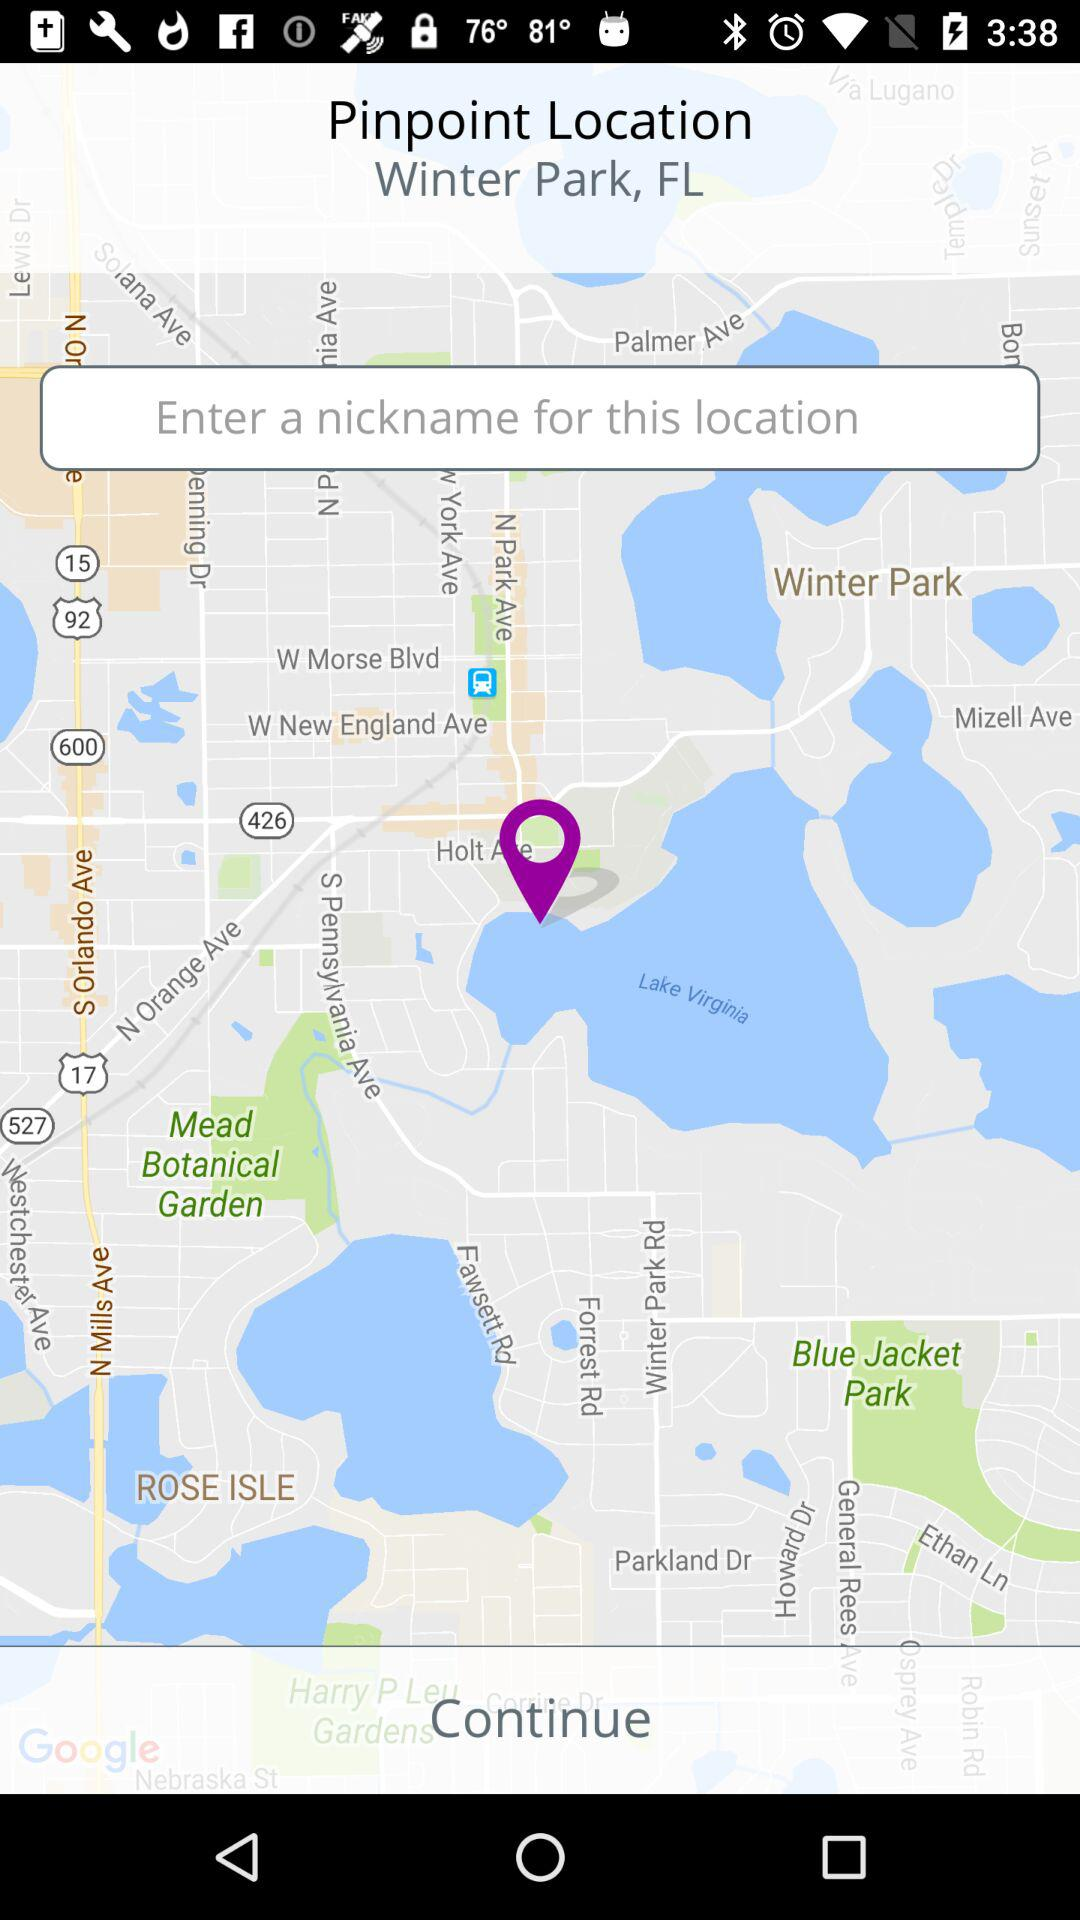How many text input fields are there on this screen?
Answer the question using a single word or phrase. 1 